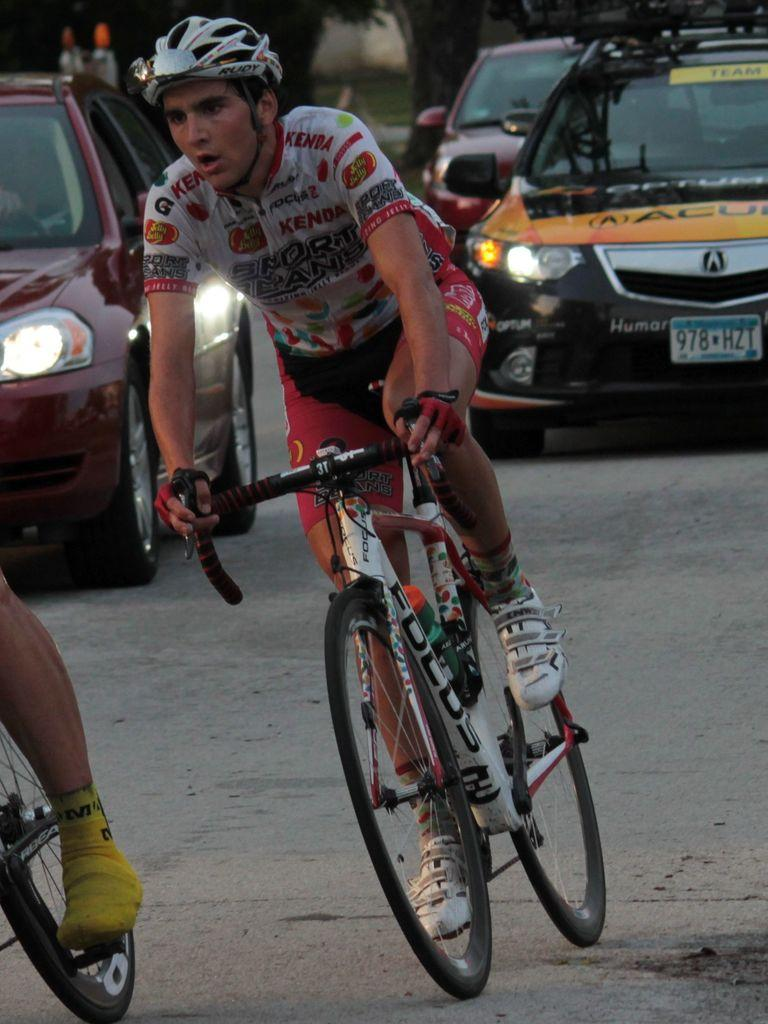What types of vehicles are present in the image? There are cars in the image. What are the people in the image doing? The people in the image are riding bicycles on the road. Where is the scarecrow located in the image? There is no scarecrow present in the image. What type of sail can be seen on the road in the image? There is no sail present in the image, as it is a road scene with cars and bicycles. 